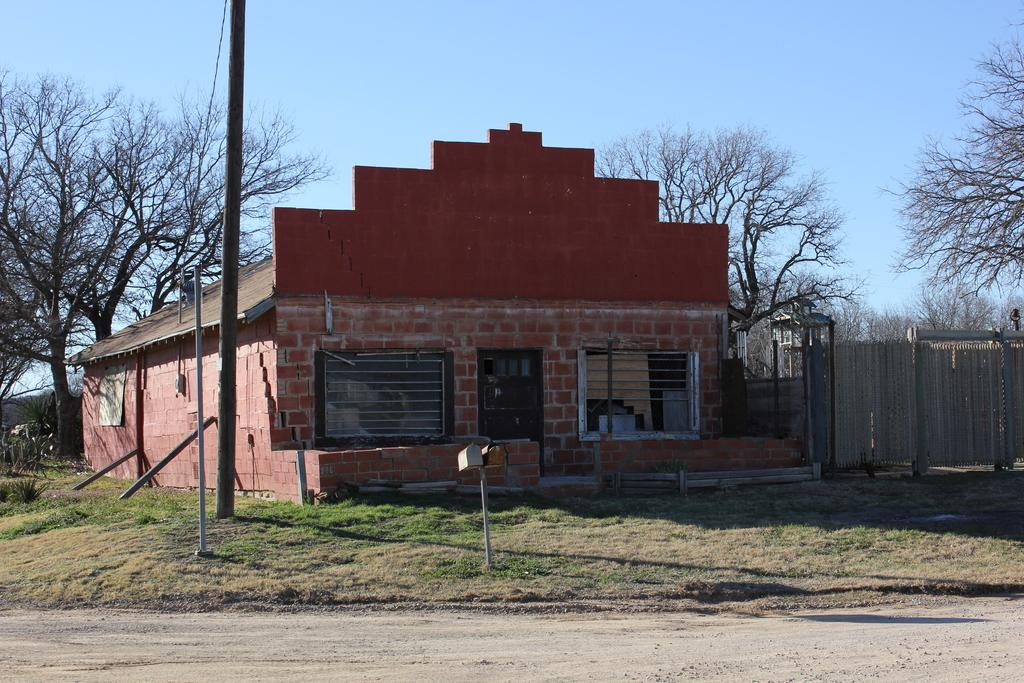What type of structure is visible in the image? There is a house in the image. What other objects can be seen in the image? There are poles, trees, grass, a fence, and a path visible in the image. What is the terrain like in the image? The terrain includes grass and trees. What is visible at the top of the image? The sky is visible in the image. How can someone access the house in the image? The path at the bottom of the image suggests a possible way to access the house. What type of finger can be seen pointing at the house in the image? There are no fingers visible in the image; it only features a house, poles, trees, grass, a fence, a path, and the sky. 